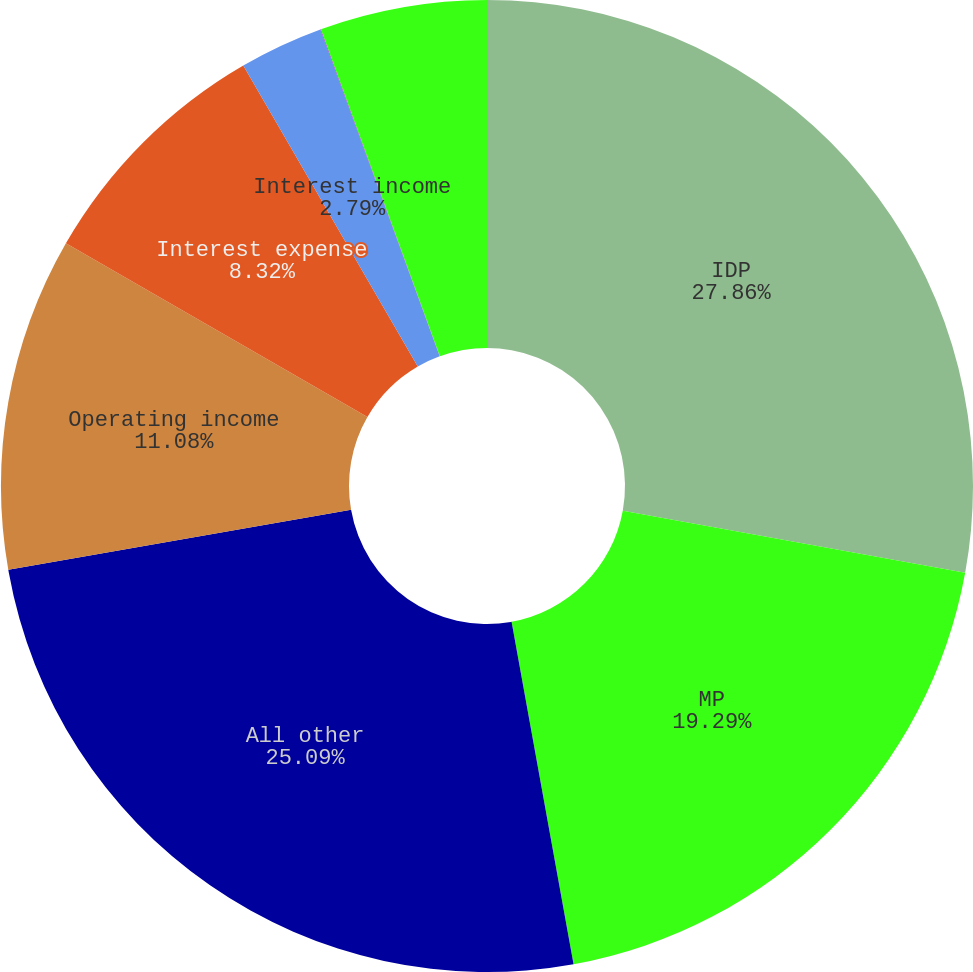<chart> <loc_0><loc_0><loc_500><loc_500><pie_chart><fcel>IDP<fcel>MP<fcel>All other<fcel>Operating income<fcel>Interest expense<fcel>Interest income<fcel>Other expense (Note 8)<fcel>Income before income taxes<nl><fcel>27.86%<fcel>19.29%<fcel>25.09%<fcel>11.08%<fcel>8.32%<fcel>2.79%<fcel>0.02%<fcel>5.55%<nl></chart> 